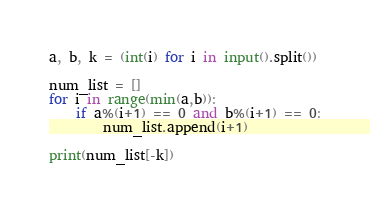Convert code to text. <code><loc_0><loc_0><loc_500><loc_500><_Python_>a, b, k = (int(i) for i in input().split())

num_list = []
for i in range(min(a,b)):
    if a%(i+1) == 0 and b%(i+1) == 0:
        num_list.append(i+1)

print(num_list[-k])</code> 